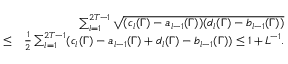<formula> <loc_0><loc_0><loc_500><loc_500>\begin{array} { r l r } & { \sum _ { l = 1 } ^ { 2 T - 1 } \sqrt { ( c _ { l } ( \Gamma ) - a _ { l - 1 } ( \Gamma ) ) ( d _ { l } ( \Gamma ) - b _ { l - 1 } ( \Gamma ) ) } } \\ & { \leq } & { \frac { 1 } { 2 } \sum _ { l = 1 } ^ { 2 T - 1 } ( c _ { l } ( \Gamma ) - a _ { l - 1 } ( \Gamma ) + d _ { l } ( \Gamma ) - b _ { l - 1 } ( \Gamma ) ) \leq 1 + L ^ { - 1 } . } \end{array}</formula> 